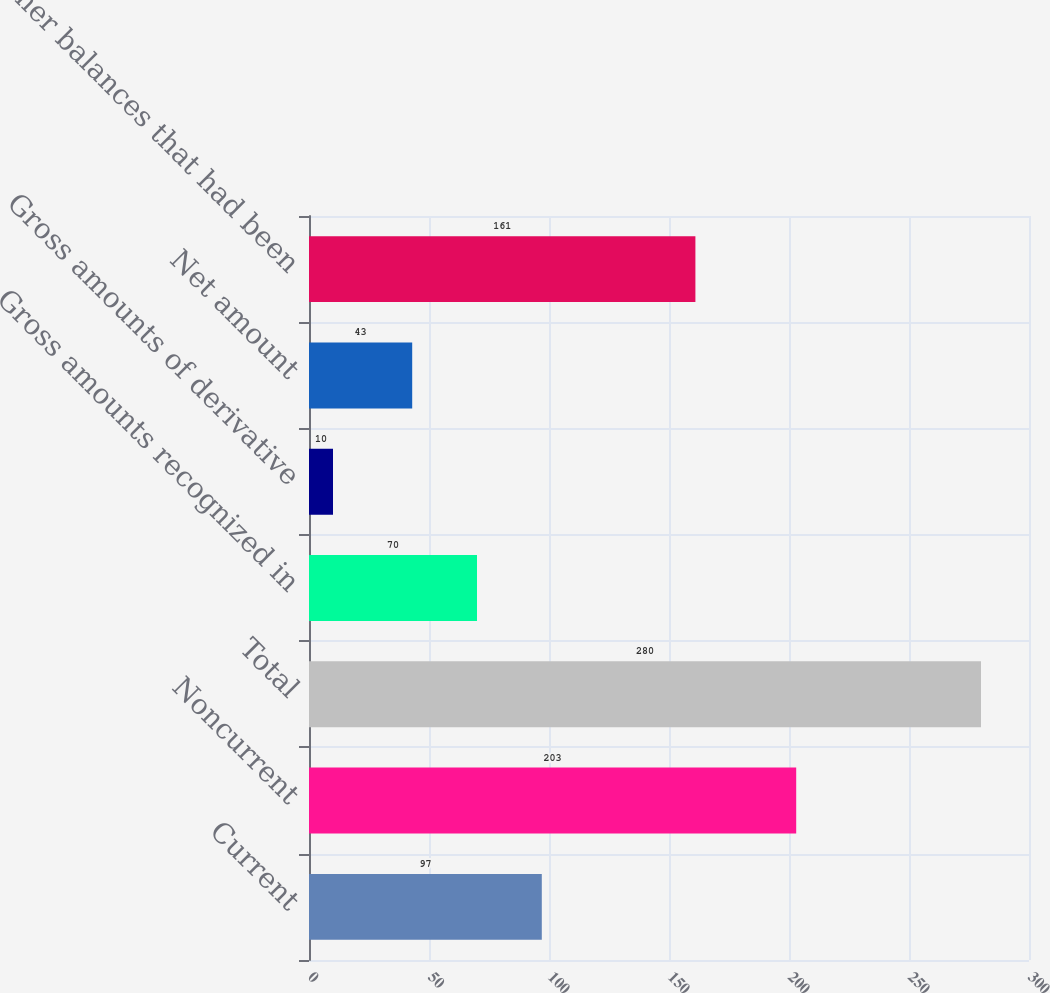<chart> <loc_0><loc_0><loc_500><loc_500><bar_chart><fcel>Current<fcel>Noncurrent<fcel>Total<fcel>Gross amounts recognized in<fcel>Gross amounts of derivative<fcel>Net amount<fcel>Other balances that had been<nl><fcel>97<fcel>203<fcel>280<fcel>70<fcel>10<fcel>43<fcel>161<nl></chart> 